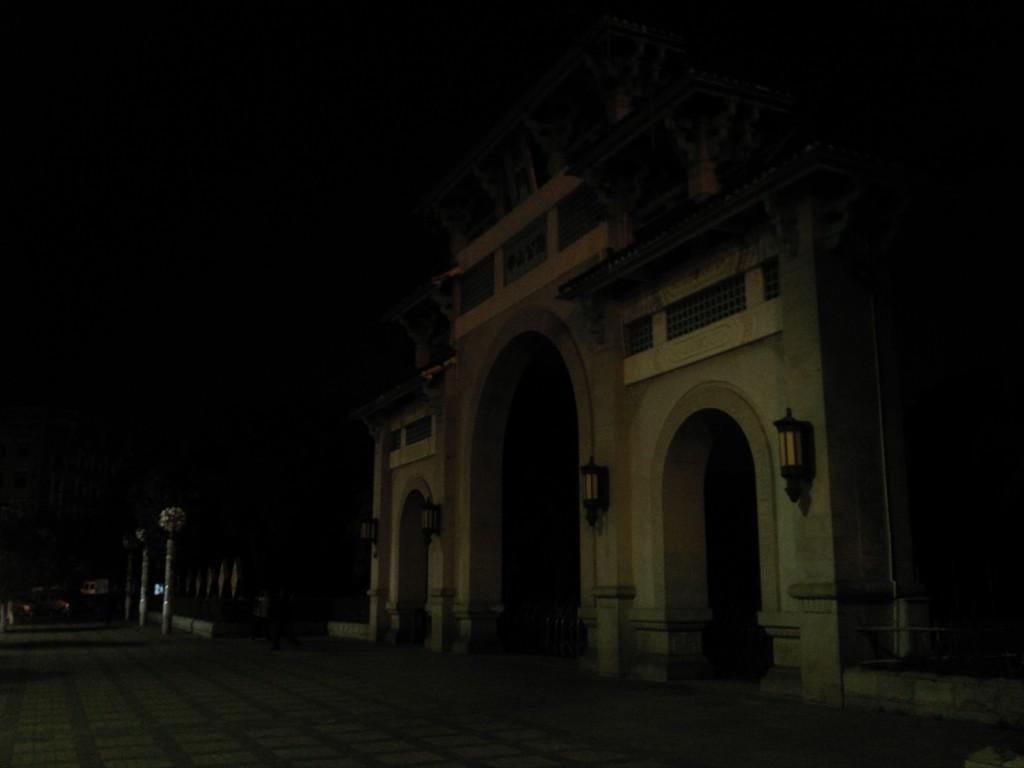In one or two sentences, can you explain what this image depicts? In this picture we can see a brown color building in the front with the hanging lights. In the front bottom side there is a walking area. Behind there is a dark background. 